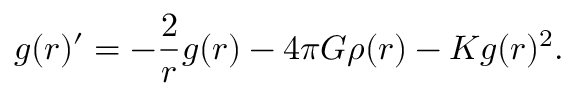Convert formula to latex. <formula><loc_0><loc_0><loc_500><loc_500>g ( r ) ^ { \prime } = - \frac { 2 } { r } g ( r ) - 4 \pi G \rho ( r ) - K g ( r ) ^ { 2 } .</formula> 